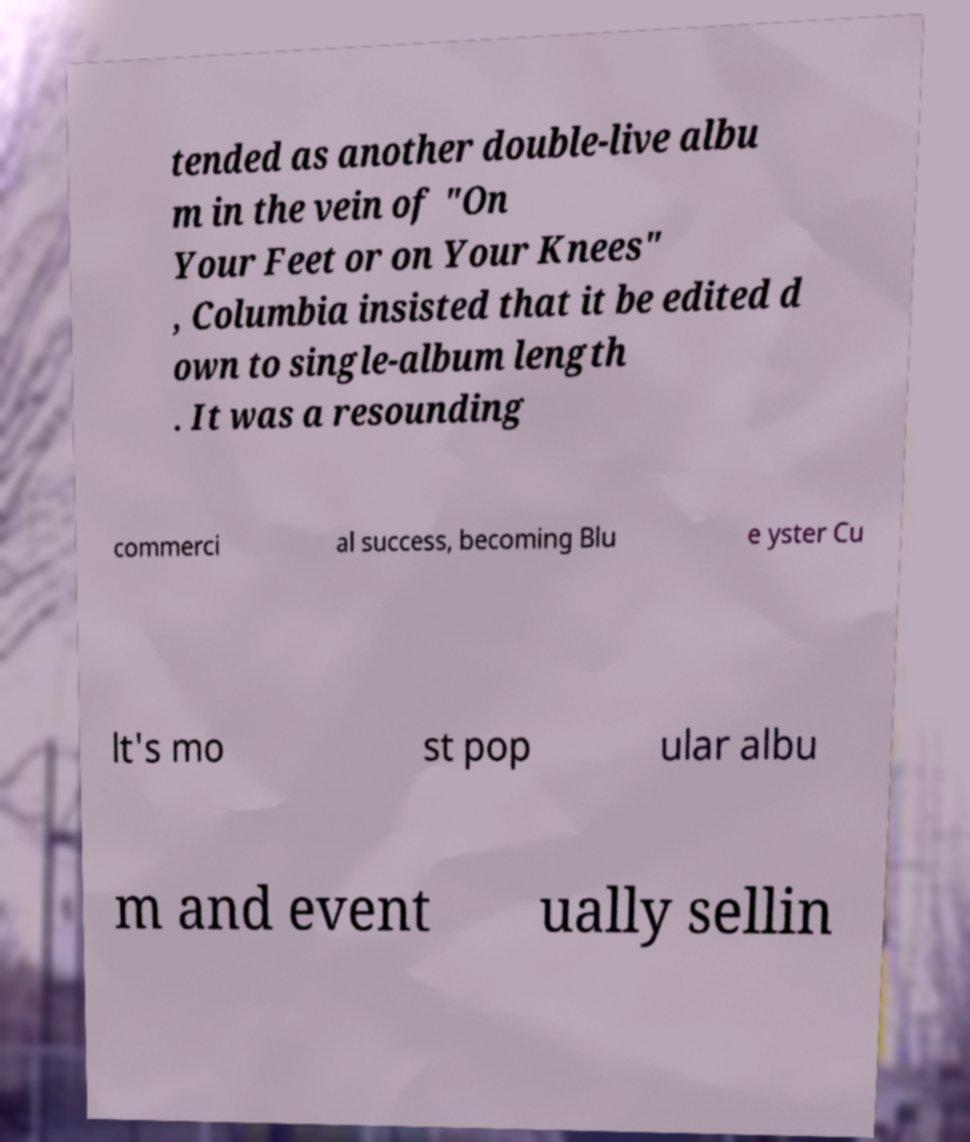For documentation purposes, I need the text within this image transcribed. Could you provide that? tended as another double-live albu m in the vein of "On Your Feet or on Your Knees" , Columbia insisted that it be edited d own to single-album length . It was a resounding commerci al success, becoming Blu e yster Cu lt's mo st pop ular albu m and event ually sellin 